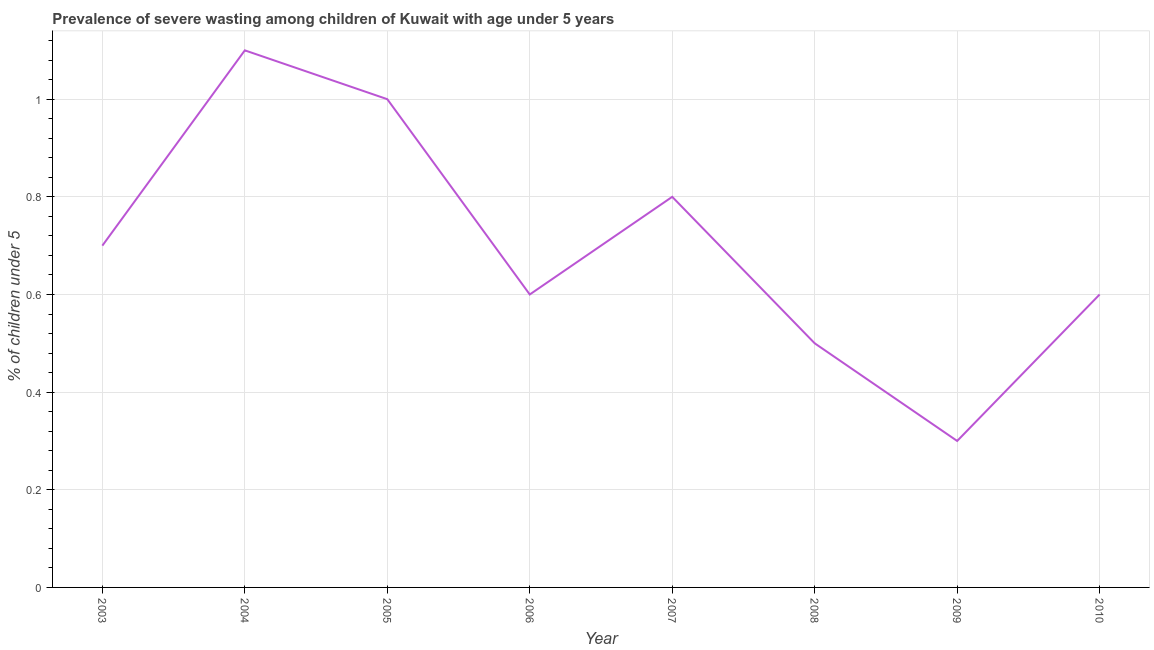What is the prevalence of severe wasting in 2007?
Provide a short and direct response. 0.8. Across all years, what is the maximum prevalence of severe wasting?
Provide a short and direct response. 1.1. Across all years, what is the minimum prevalence of severe wasting?
Offer a terse response. 0.3. What is the sum of the prevalence of severe wasting?
Give a very brief answer. 5.6. What is the difference between the prevalence of severe wasting in 2003 and 2006?
Your answer should be compact. 0.1. What is the average prevalence of severe wasting per year?
Offer a very short reply. 0.7. What is the median prevalence of severe wasting?
Offer a very short reply. 0.65. In how many years, is the prevalence of severe wasting greater than 0.2 %?
Your answer should be very brief. 8. Do a majority of the years between 2010 and 2006 (inclusive) have prevalence of severe wasting greater than 0.92 %?
Offer a terse response. Yes. What is the ratio of the prevalence of severe wasting in 2008 to that in 2010?
Provide a succinct answer. 0.83. Is the difference between the prevalence of severe wasting in 2005 and 2010 greater than the difference between any two years?
Your answer should be compact. No. What is the difference between the highest and the second highest prevalence of severe wasting?
Your answer should be very brief. 0.1. What is the difference between the highest and the lowest prevalence of severe wasting?
Give a very brief answer. 0.8. In how many years, is the prevalence of severe wasting greater than the average prevalence of severe wasting taken over all years?
Provide a succinct answer. 3. How many years are there in the graph?
Your answer should be very brief. 8. What is the difference between two consecutive major ticks on the Y-axis?
Keep it short and to the point. 0.2. Are the values on the major ticks of Y-axis written in scientific E-notation?
Ensure brevity in your answer.  No. Does the graph contain any zero values?
Provide a short and direct response. No. Does the graph contain grids?
Ensure brevity in your answer.  Yes. What is the title of the graph?
Offer a very short reply. Prevalence of severe wasting among children of Kuwait with age under 5 years. What is the label or title of the Y-axis?
Ensure brevity in your answer.   % of children under 5. What is the  % of children under 5 of 2003?
Offer a very short reply. 0.7. What is the  % of children under 5 of 2004?
Provide a short and direct response. 1.1. What is the  % of children under 5 of 2005?
Provide a short and direct response. 1. What is the  % of children under 5 in 2006?
Your answer should be very brief. 0.6. What is the  % of children under 5 in 2007?
Offer a terse response. 0.8. What is the  % of children under 5 of 2009?
Provide a short and direct response. 0.3. What is the  % of children under 5 of 2010?
Provide a succinct answer. 0.6. What is the difference between the  % of children under 5 in 2003 and 2006?
Ensure brevity in your answer.  0.1. What is the difference between the  % of children under 5 in 2003 and 2009?
Ensure brevity in your answer.  0.4. What is the difference between the  % of children under 5 in 2003 and 2010?
Provide a short and direct response. 0.1. What is the difference between the  % of children under 5 in 2004 and 2006?
Keep it short and to the point. 0.5. What is the difference between the  % of children under 5 in 2004 and 2008?
Give a very brief answer. 0.6. What is the difference between the  % of children under 5 in 2004 and 2009?
Keep it short and to the point. 0.8. What is the difference between the  % of children under 5 in 2005 and 2006?
Ensure brevity in your answer.  0.4. What is the difference between the  % of children under 5 in 2005 and 2007?
Give a very brief answer. 0.2. What is the difference between the  % of children under 5 in 2005 and 2008?
Make the answer very short. 0.5. What is the difference between the  % of children under 5 in 2006 and 2008?
Your answer should be very brief. 0.1. What is the difference between the  % of children under 5 in 2006 and 2010?
Provide a short and direct response. 0. What is the difference between the  % of children under 5 in 2007 and 2009?
Keep it short and to the point. 0.5. What is the difference between the  % of children under 5 in 2007 and 2010?
Your answer should be very brief. 0.2. What is the difference between the  % of children under 5 in 2008 and 2009?
Provide a succinct answer. 0.2. What is the ratio of the  % of children under 5 in 2003 to that in 2004?
Provide a succinct answer. 0.64. What is the ratio of the  % of children under 5 in 2003 to that in 2005?
Make the answer very short. 0.7. What is the ratio of the  % of children under 5 in 2003 to that in 2006?
Offer a terse response. 1.17. What is the ratio of the  % of children under 5 in 2003 to that in 2009?
Your answer should be very brief. 2.33. What is the ratio of the  % of children under 5 in 2003 to that in 2010?
Your response must be concise. 1.17. What is the ratio of the  % of children under 5 in 2004 to that in 2005?
Your answer should be compact. 1.1. What is the ratio of the  % of children under 5 in 2004 to that in 2006?
Give a very brief answer. 1.83. What is the ratio of the  % of children under 5 in 2004 to that in 2007?
Provide a short and direct response. 1.38. What is the ratio of the  % of children under 5 in 2004 to that in 2009?
Your answer should be very brief. 3.67. What is the ratio of the  % of children under 5 in 2004 to that in 2010?
Give a very brief answer. 1.83. What is the ratio of the  % of children under 5 in 2005 to that in 2006?
Provide a short and direct response. 1.67. What is the ratio of the  % of children under 5 in 2005 to that in 2007?
Ensure brevity in your answer.  1.25. What is the ratio of the  % of children under 5 in 2005 to that in 2009?
Keep it short and to the point. 3.33. What is the ratio of the  % of children under 5 in 2005 to that in 2010?
Ensure brevity in your answer.  1.67. What is the ratio of the  % of children under 5 in 2006 to that in 2008?
Your answer should be compact. 1.2. What is the ratio of the  % of children under 5 in 2006 to that in 2010?
Provide a succinct answer. 1. What is the ratio of the  % of children under 5 in 2007 to that in 2009?
Your answer should be compact. 2.67. What is the ratio of the  % of children under 5 in 2007 to that in 2010?
Your answer should be very brief. 1.33. What is the ratio of the  % of children under 5 in 2008 to that in 2009?
Make the answer very short. 1.67. What is the ratio of the  % of children under 5 in 2008 to that in 2010?
Your answer should be very brief. 0.83. 